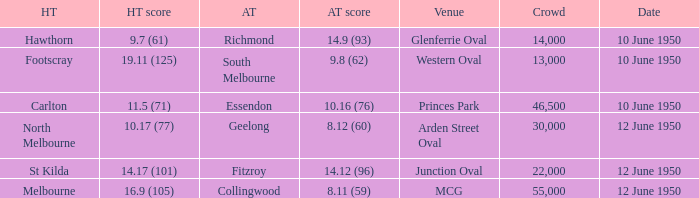What was the crowd when the VFL played MCG? 55000.0. Can you give me this table as a dict? {'header': ['HT', 'HT score', 'AT', 'AT score', 'Venue', 'Crowd', 'Date'], 'rows': [['Hawthorn', '9.7 (61)', 'Richmond', '14.9 (93)', 'Glenferrie Oval', '14,000', '10 June 1950'], ['Footscray', '19.11 (125)', 'South Melbourne', '9.8 (62)', 'Western Oval', '13,000', '10 June 1950'], ['Carlton', '11.5 (71)', 'Essendon', '10.16 (76)', 'Princes Park', '46,500', '10 June 1950'], ['North Melbourne', '10.17 (77)', 'Geelong', '8.12 (60)', 'Arden Street Oval', '30,000', '12 June 1950'], ['St Kilda', '14.17 (101)', 'Fitzroy', '14.12 (96)', 'Junction Oval', '22,000', '12 June 1950'], ['Melbourne', '16.9 (105)', 'Collingwood', '8.11 (59)', 'MCG', '55,000', '12 June 1950']]} 